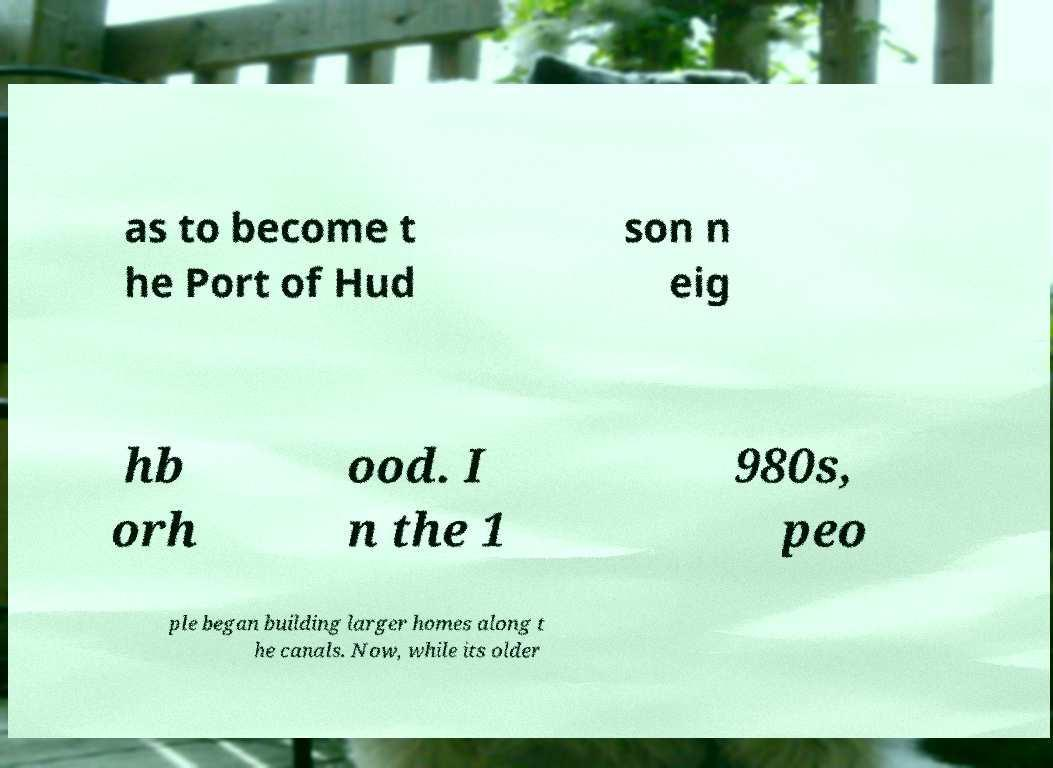I need the written content from this picture converted into text. Can you do that? as to become t he Port of Hud son n eig hb orh ood. I n the 1 980s, peo ple began building larger homes along t he canals. Now, while its older 